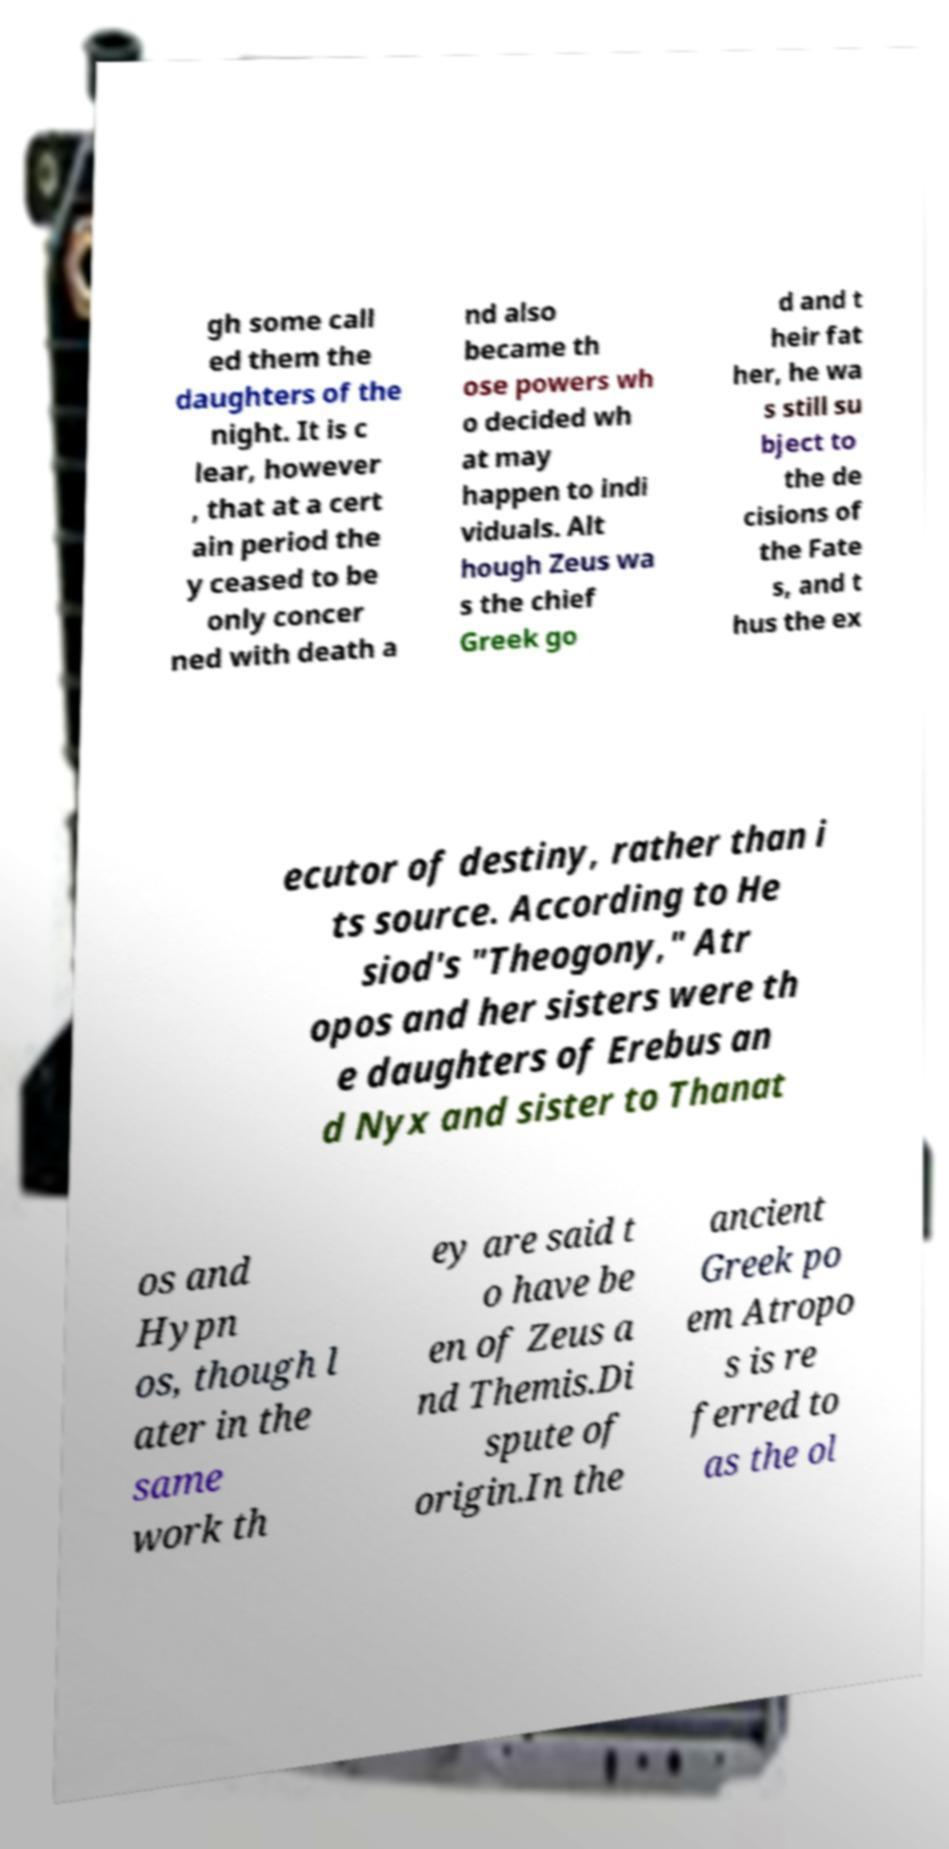There's text embedded in this image that I need extracted. Can you transcribe it verbatim? gh some call ed them the daughters of the night. It is c lear, however , that at a cert ain period the y ceased to be only concer ned with death a nd also became th ose powers wh o decided wh at may happen to indi viduals. Alt hough Zeus wa s the chief Greek go d and t heir fat her, he wa s still su bject to the de cisions of the Fate s, and t hus the ex ecutor of destiny, rather than i ts source. According to He siod's "Theogony," Atr opos and her sisters were th e daughters of Erebus an d Nyx and sister to Thanat os and Hypn os, though l ater in the same work th ey are said t o have be en of Zeus a nd Themis.Di spute of origin.In the ancient Greek po em Atropo s is re ferred to as the ol 